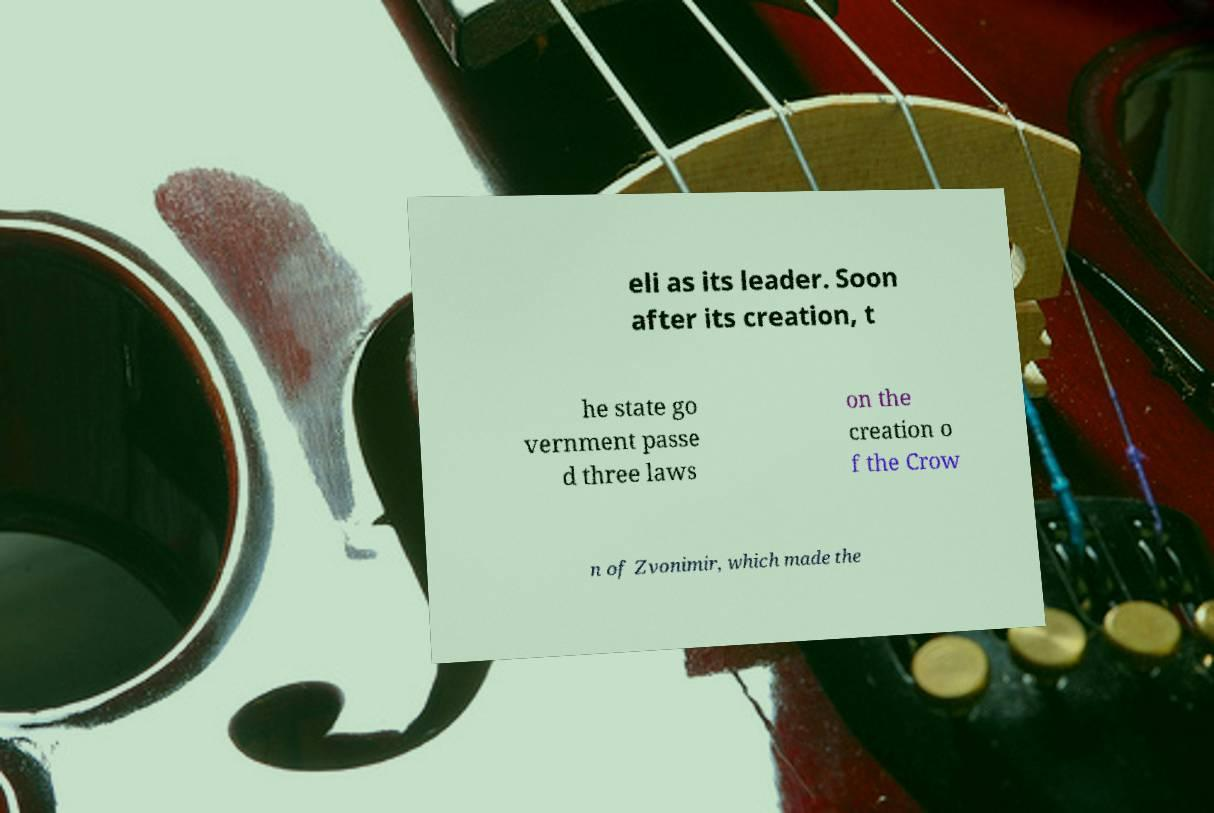Could you assist in decoding the text presented in this image and type it out clearly? eli as its leader. Soon after its creation, t he state go vernment passe d three laws on the creation o f the Crow n of Zvonimir, which made the 